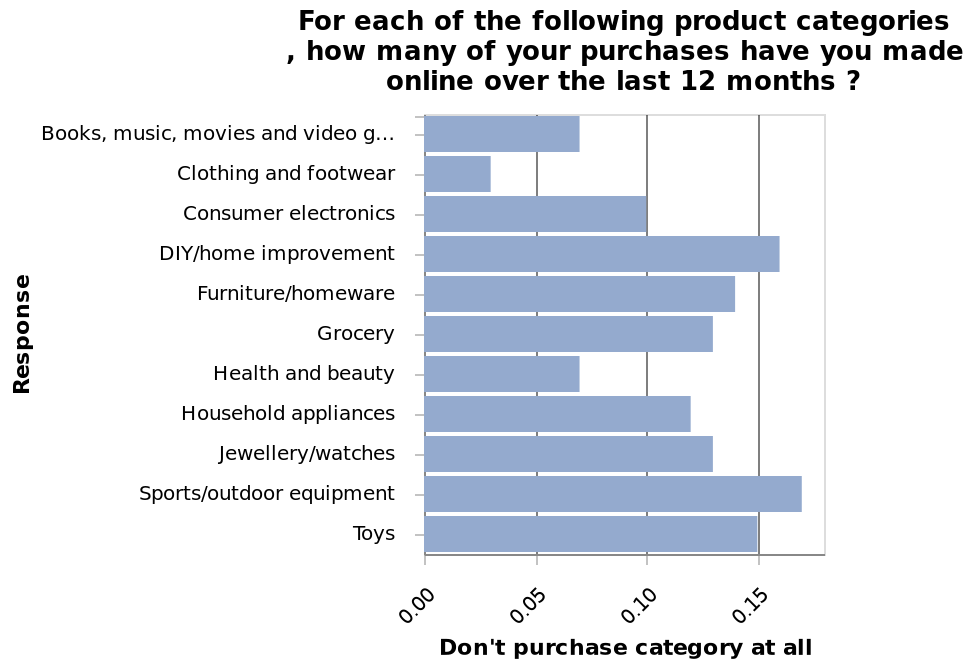<image>
Describe the following image in detail For each of the following product categories , how many of your purchases have you made online over the last 12 months ? is a bar diagram. A scale with a minimum of 0.00 and a maximum of 0.15 can be found on the x-axis, labeled Don't purchase category at all. A categorical scale with Books, music, movies and video games on one end and  at the other can be found along the y-axis, labeled Response. Which product category has the highest number of online purchases made over the last 12 months?  By referring to the bar diagram's y-axis, you can identify the product category with the highest number of online purchases made over the last 12 months. What is the maximum scale value on the x-axis of the bar diagram?  The maximum scale value on the x-axis of the bar diagram is 0.15, labeled as "Don't purchase category at all." 